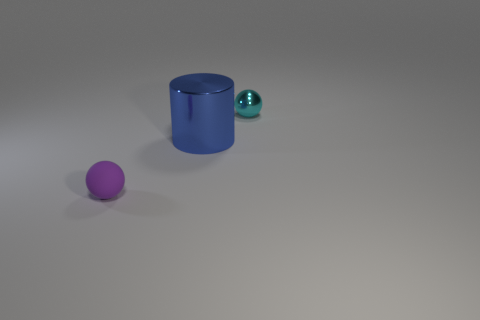Add 3 metal spheres. How many objects exist? 6 Subtract all cylinders. How many objects are left? 2 Add 3 large metallic cylinders. How many large metallic cylinders are left? 4 Add 3 cyan shiny objects. How many cyan shiny objects exist? 4 Subtract 0 yellow balls. How many objects are left? 3 Subtract all big rubber things. Subtract all matte things. How many objects are left? 2 